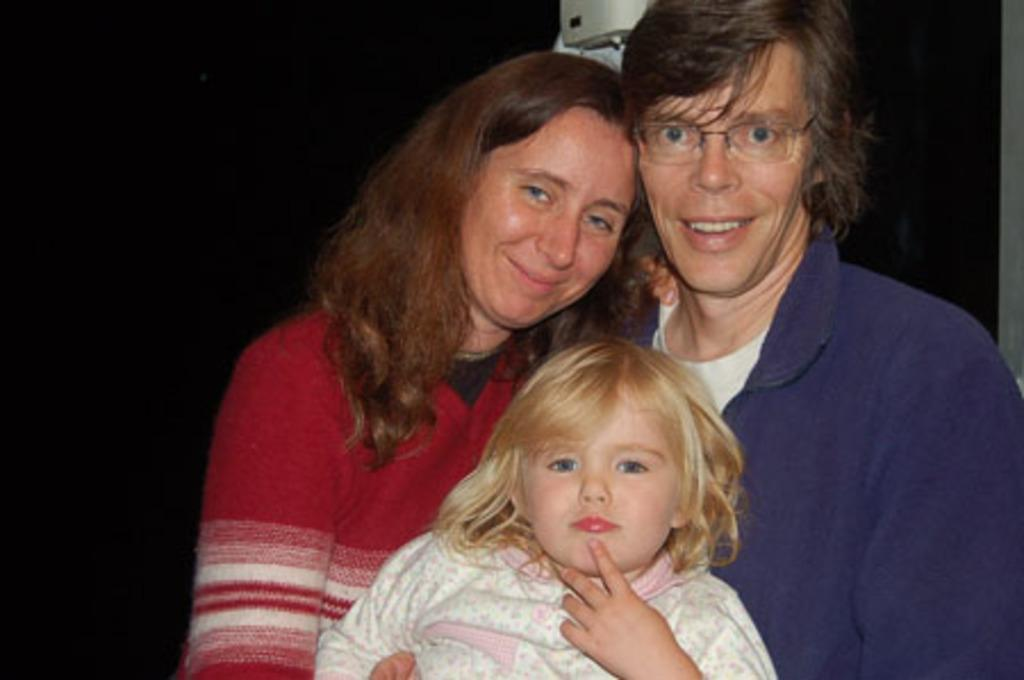Who is present in the image? There is a woman and a girl in the image. Can you describe the appearance of one of the individuals? There is a person wearing spectacles in the image. What is the main object in the image? There is an object in the image, but its specific nature is not mentioned in the facts. What is the color of the background in the image? The background of the image is black. What type of bears can be seen playing with a notebook in the image? There are no bears or notebooks present in the image. How many bears are wearing a slip in the image? There are no bears or slips present in the image. 